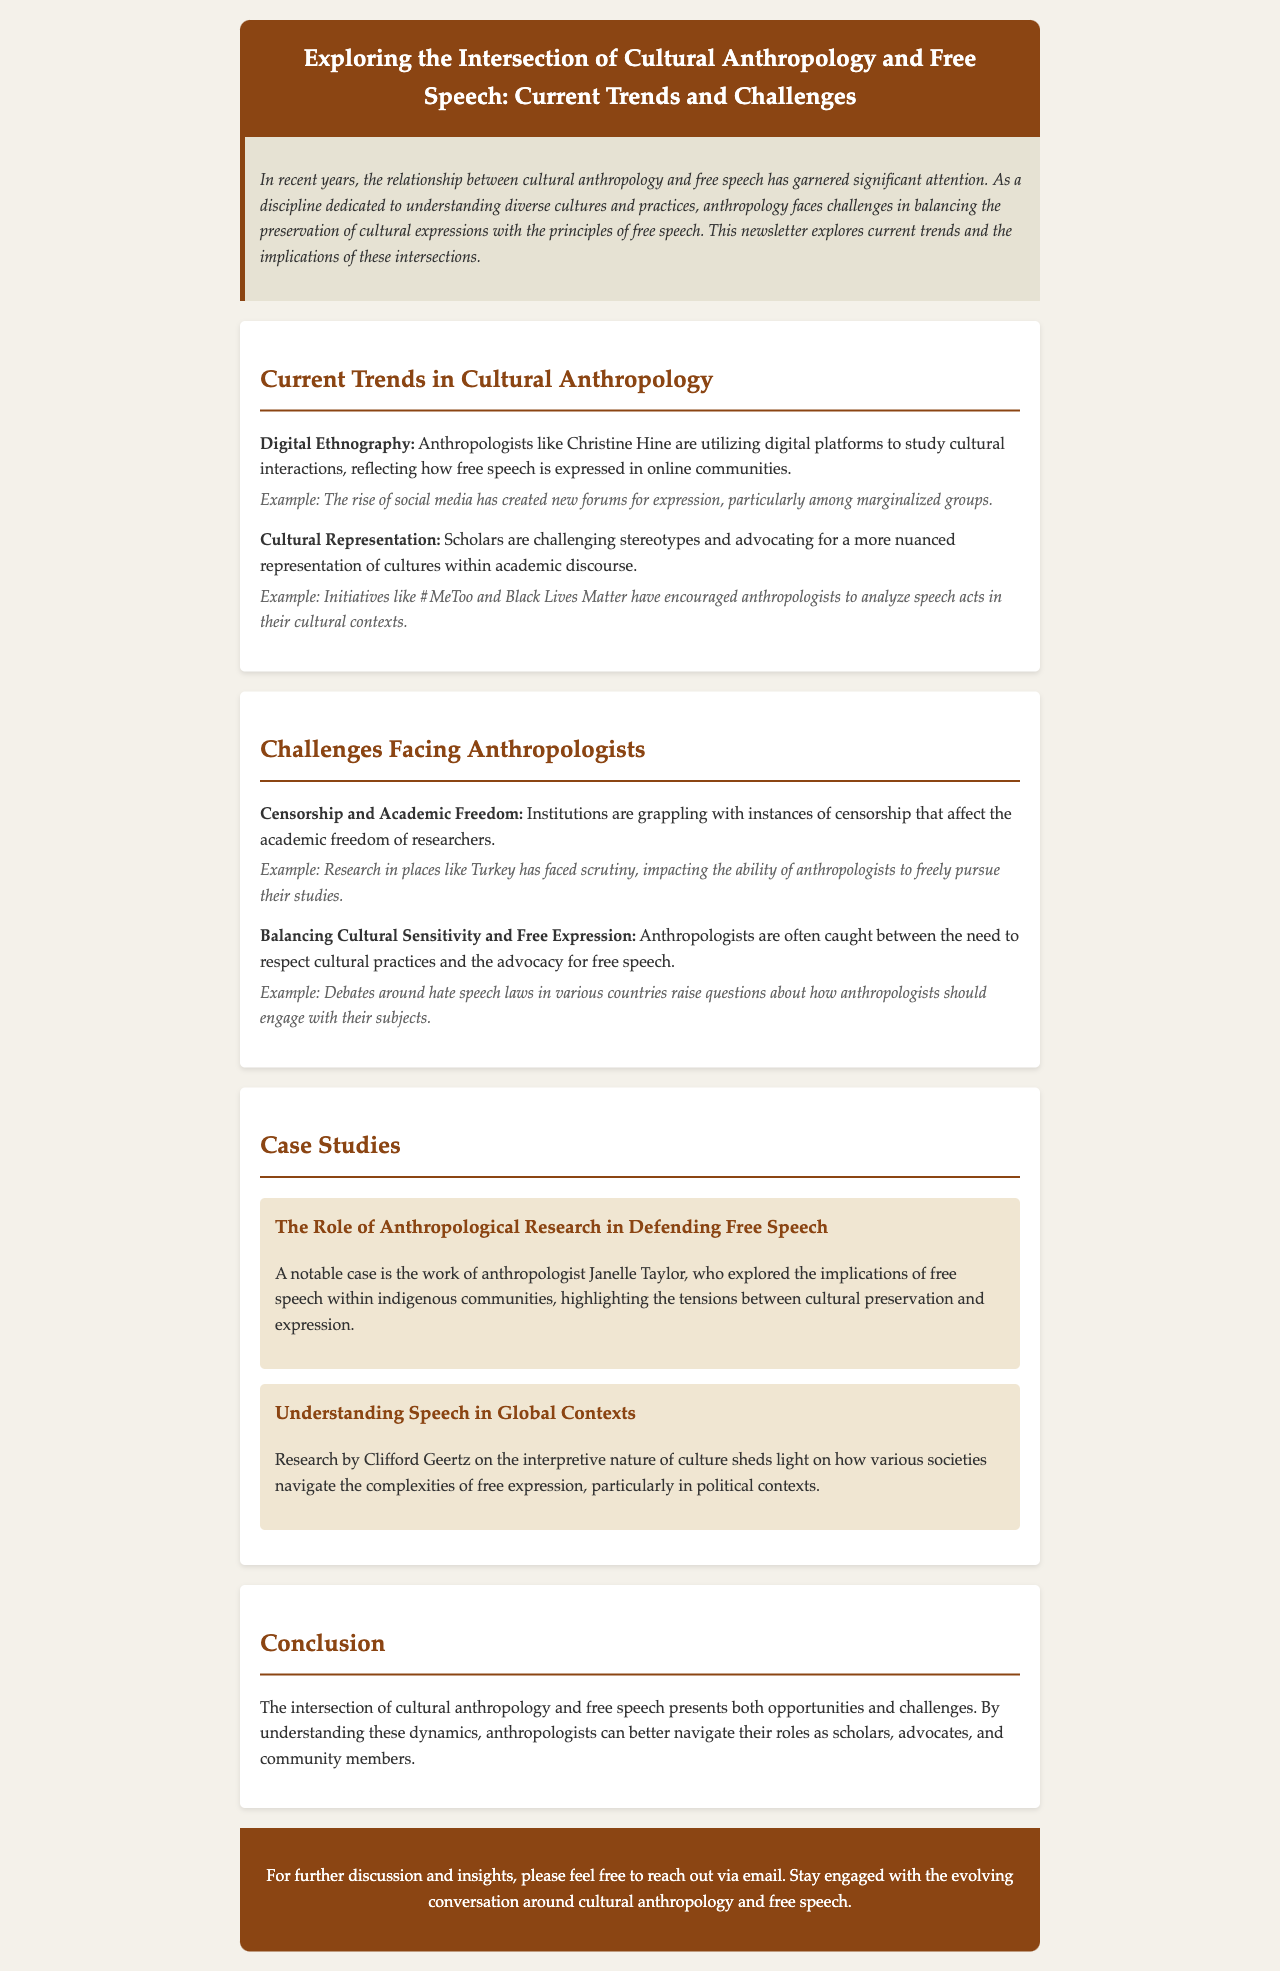What is the title of the newsletter? The title is provided in the header of the document.
Answer: Exploring the Intersection of Cultural Anthropology and Free Speech: Current Trends and Challenges Who is mentioned as an anthropologist utilizing digital platforms? The document specifies anthropologists and gives an example of Christine Hine.
Answer: Christine Hine What are two initiatives that have encouraged nuanced cultural analysis? The document lists #MeToo and Black Lives Matter as key initiatives.
Answer: #MeToo and Black Lives Matter What is one challenge related to censorship faced by anthropologists? The document mentions censorship affecting academic freedom as a challenge for researchers.
Answer: Academic Freedom In what country has research faced scrutiny, affecting anthropologists? The document specifically mentions Turkey as a location where research faced issues.
Answer: Turkey What does Clifford Geertz's research focus on according to the document? The document describes his research as exploring the interpretive nature of culture.
Answer: Interpretive nature of culture What is a key implication raised by Janelle Taylor's research? The document states her work highlights tensions between cultural preservation and expression.
Answer: Tensions between cultural preservation and expression What are anthropologists encouraged to understand better for their role? The document emphasizes understanding the dynamics between cultural anthropology and free speech.
Answer: Dynamics between cultural anthropology and free speech 